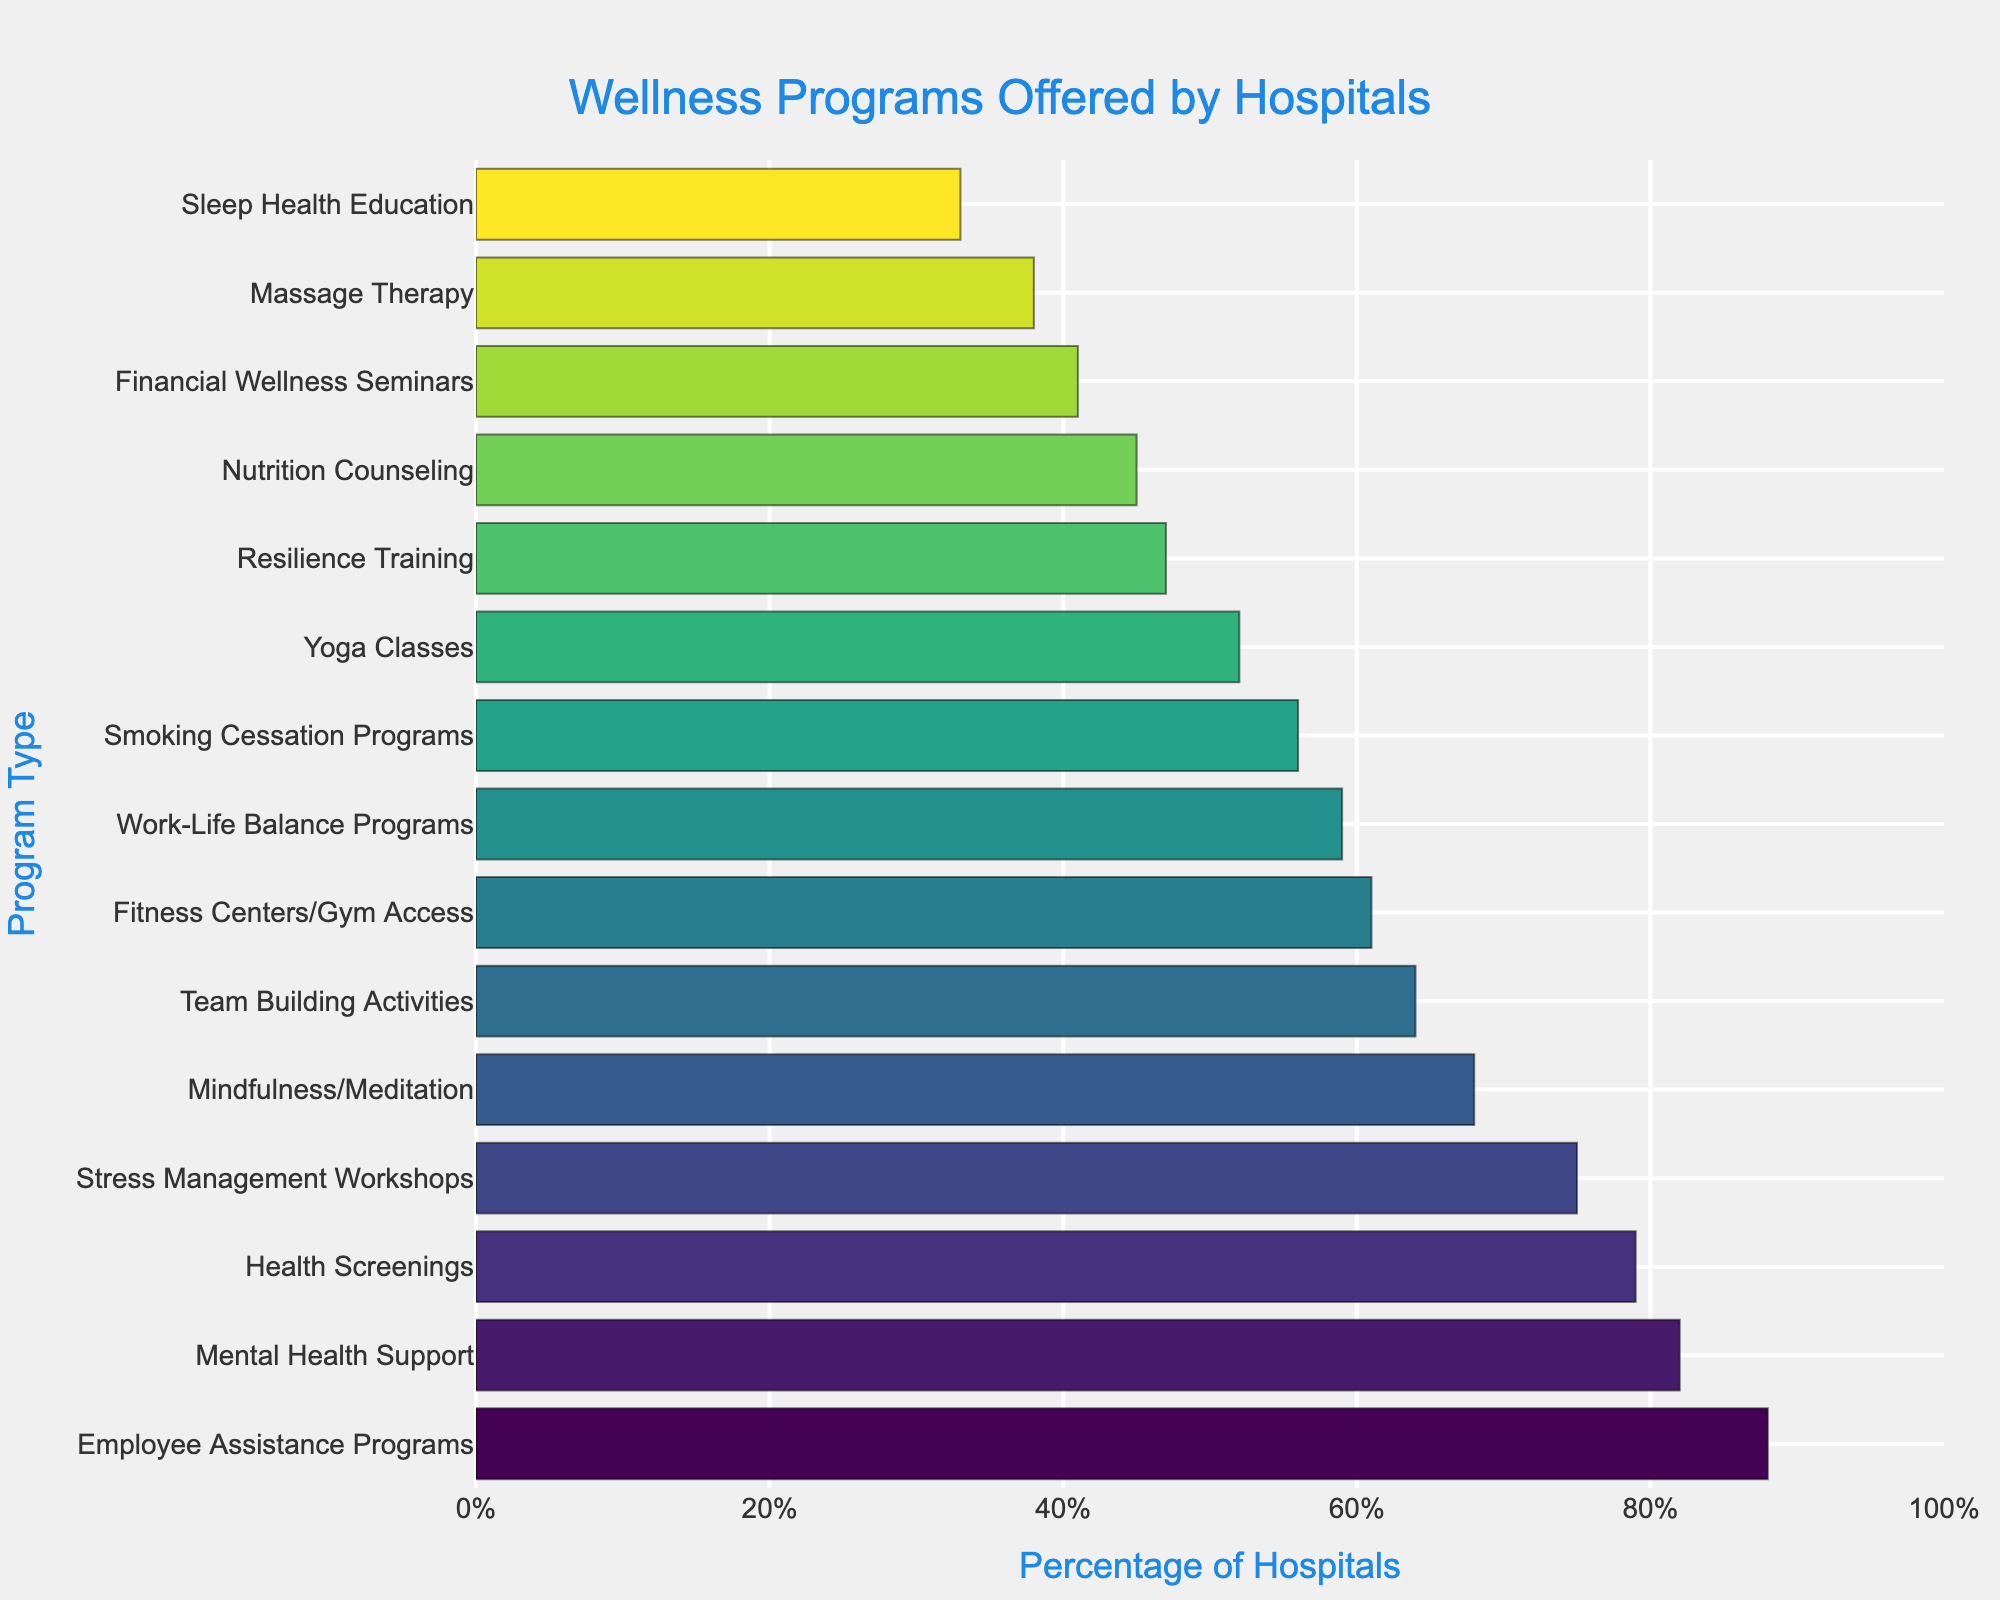Which program type is offered by the highest percentage of hospitals? The program type offered by the highest percentage of hospitals is identified by looking for the tallest bar.
Answer: Employee Assistance Programs Which program has a higher percentage of hospitals offering it: Yoga Classes or Fitness Centers/Gym Access? Compare the length of the bars corresponding to Yoga Classes and Fitness Centers/Gym Access.
Answer: Fitness Centers/Gym Access What is the average percentage of hospitals offering Mindfulness/Meditation, Yoga Classes, and Stress Management Workshops? Add the percentages for Mindfulness/Meditation, Yoga Classes, and Stress Management Workshops and divide by 3. (68 + 52 + 75) = 195; 195 / 3 = 65
Answer: 65 Is the percentage of hospitals offering Nutrition Counseling higher or lower than those offering Resilience Training? Compare the lengths of the bars for Nutrition Counseling and Resilience Training.
Answer: Lower Which programs have more than 70% of hospitals offering them? Identify all program types with bars extending past the 70% mark.
Answer: Stress Management Workshops, Mental Health Support, Health Screenings, Employee Assistance Programs Which two programs have the closest percentages of hospitals offering them? Find two adjacent bars with minimal difference in length.
Answer: Stress Management Workshops and Health Screenings What is the difference in the percentage of hospitals offering Smoking Cessation Programs and Work-Life Balance Programs? Subtract the percentage of hospitals offering Work-Life Balance Programs from those offering Smoking Cessation Programs. 56 - 59 = -3
Answer: 3 Which program is the least offered by hospitals, and what is its percentage? Identify the program type with the shortest bar and read its percentage.
Answer: Sleep Health Education, 33 How does the percentage of hospitals offering Team Building Activities compare to those offering Mindfulness/Meditation? Compare the lengths of the bars for Team Building Activities and Mindfulness/Meditation.
Answer: Lower What is the total percentage of hospitals offering Employee Assistance Programs, Mental Health Support, and Health Screenings? Add the percentages for Employee Assistance Programs, Mental Health Support, and Health Screenings. 88 + 82 + 79 = 249
Answer: 249 